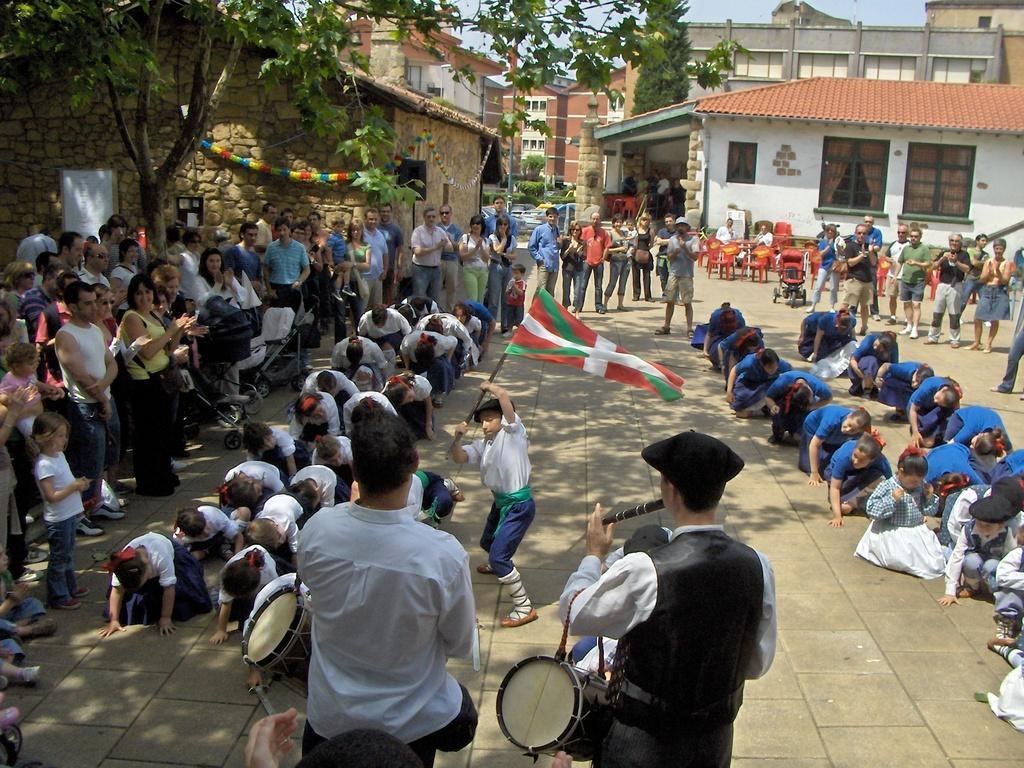In one or two sentences, can you explain what this image depicts? The group of people are watching the children's who sat on their knees and there is a kid who is wearing a white shirt is waving a flag and there a person who is wearing white and black shirt is playing music and there is in the left corner and there are buildings in the background. 